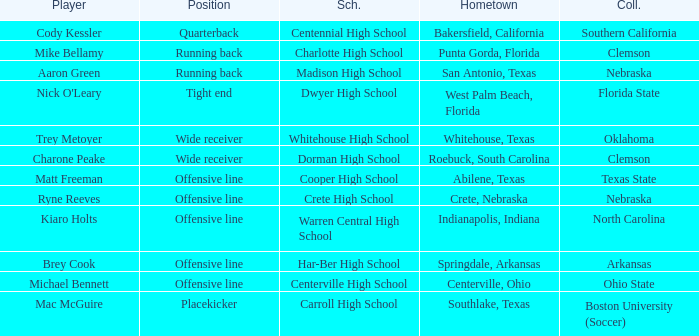What college did Matt Freeman go to? Texas State. 